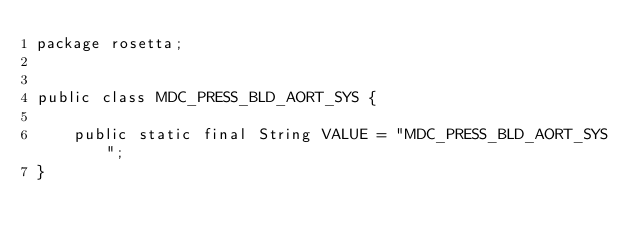Convert code to text. <code><loc_0><loc_0><loc_500><loc_500><_Java_>package rosetta;
        

public class MDC_PRESS_BLD_AORT_SYS {    
    
    public static final String VALUE = "MDC_PRESS_BLD_AORT_SYS";
}

</code> 